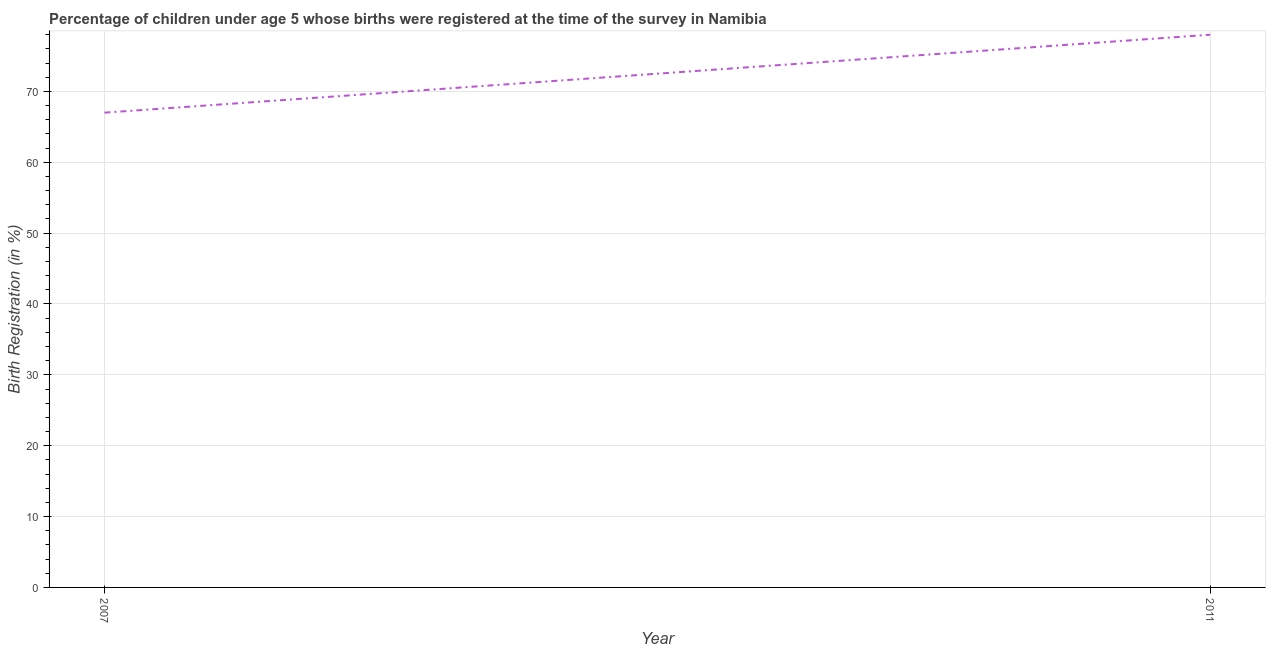What is the birth registration in 2011?
Your response must be concise. 78. Across all years, what is the maximum birth registration?
Offer a terse response. 78. Across all years, what is the minimum birth registration?
Provide a succinct answer. 67. What is the sum of the birth registration?
Provide a short and direct response. 145. What is the difference between the birth registration in 2007 and 2011?
Give a very brief answer. -11. What is the average birth registration per year?
Give a very brief answer. 72.5. What is the median birth registration?
Provide a short and direct response. 72.5. Do a majority of the years between 2011 and 2007 (inclusive) have birth registration greater than 12 %?
Keep it short and to the point. No. What is the ratio of the birth registration in 2007 to that in 2011?
Your response must be concise. 0.86. Is the birth registration in 2007 less than that in 2011?
Offer a terse response. Yes. In how many years, is the birth registration greater than the average birth registration taken over all years?
Keep it short and to the point. 1. How many years are there in the graph?
Your answer should be very brief. 2. Does the graph contain any zero values?
Your answer should be very brief. No. What is the title of the graph?
Keep it short and to the point. Percentage of children under age 5 whose births were registered at the time of the survey in Namibia. What is the label or title of the Y-axis?
Give a very brief answer. Birth Registration (in %). What is the Birth Registration (in %) in 2011?
Offer a very short reply. 78. What is the difference between the Birth Registration (in %) in 2007 and 2011?
Your answer should be compact. -11. What is the ratio of the Birth Registration (in %) in 2007 to that in 2011?
Provide a short and direct response. 0.86. 